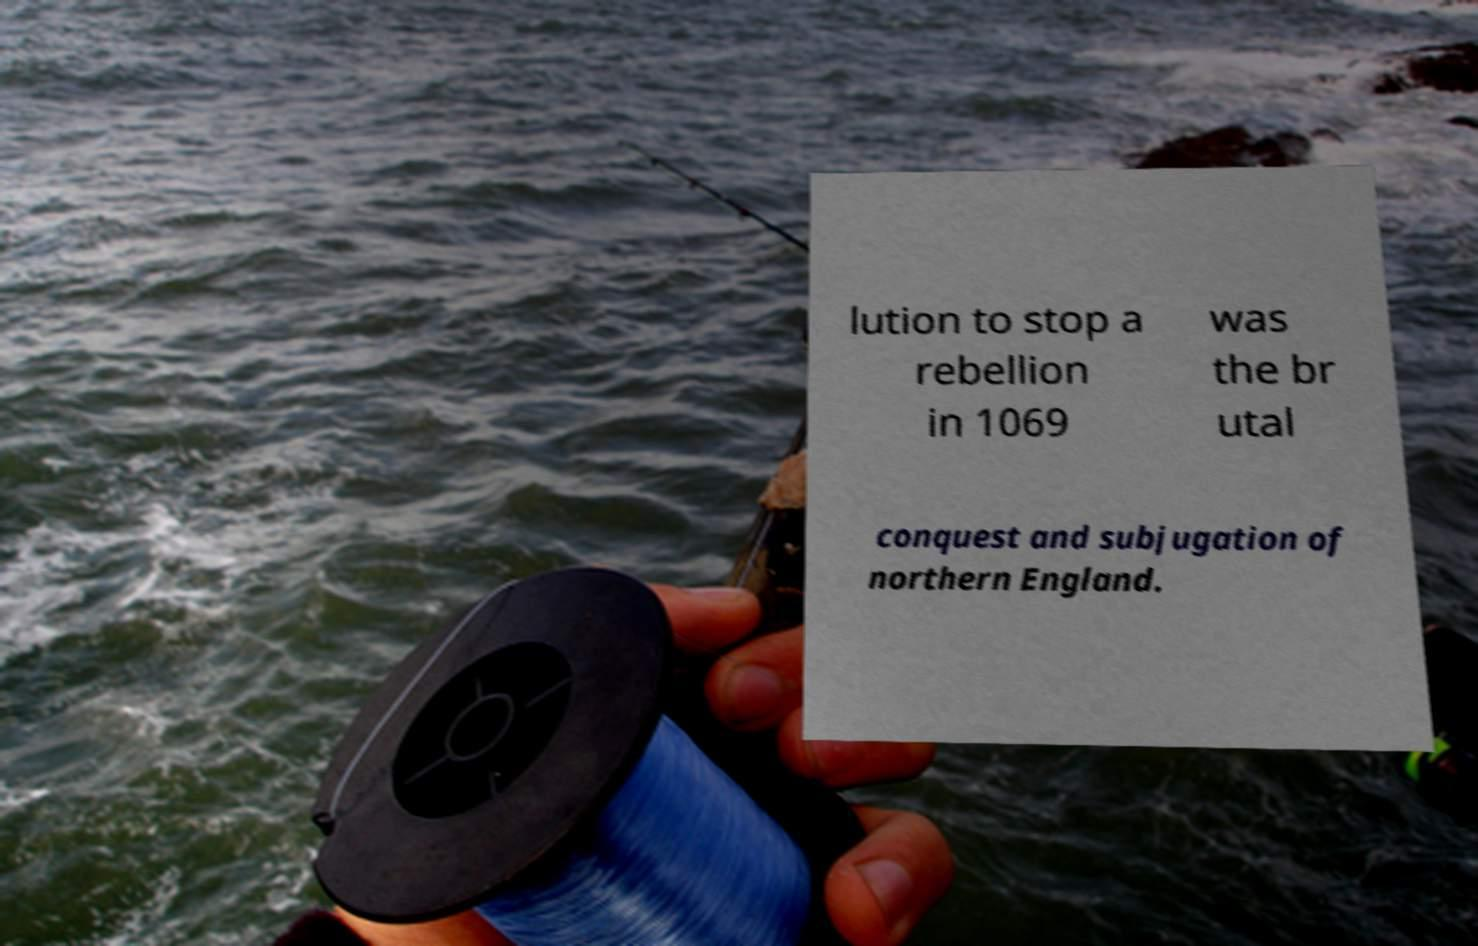What messages or text are displayed in this image? I need them in a readable, typed format. lution to stop a rebellion in 1069 was the br utal conquest and subjugation of northern England. 